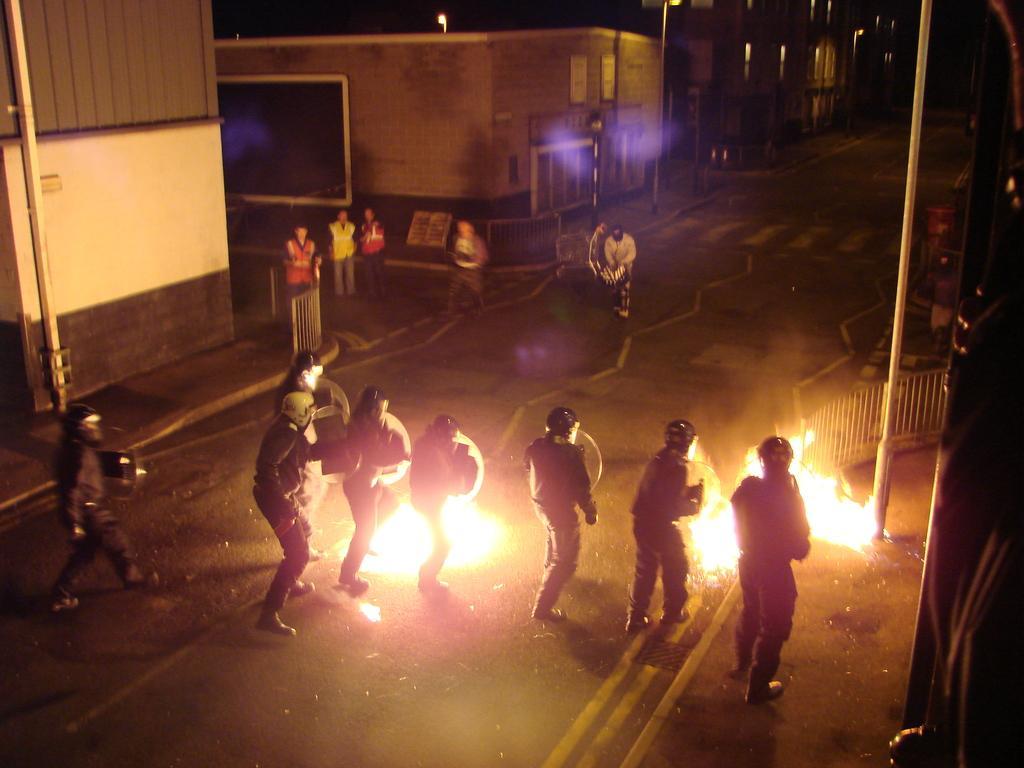Can you describe this image briefly? In this image there is road, there are people standing on the road, there are person holding objects, there is fire on the road, there are houses, there is a pole, there is an object truncated towards the right of the image, there is an object truncated towards the left of the image, there is a street light. 